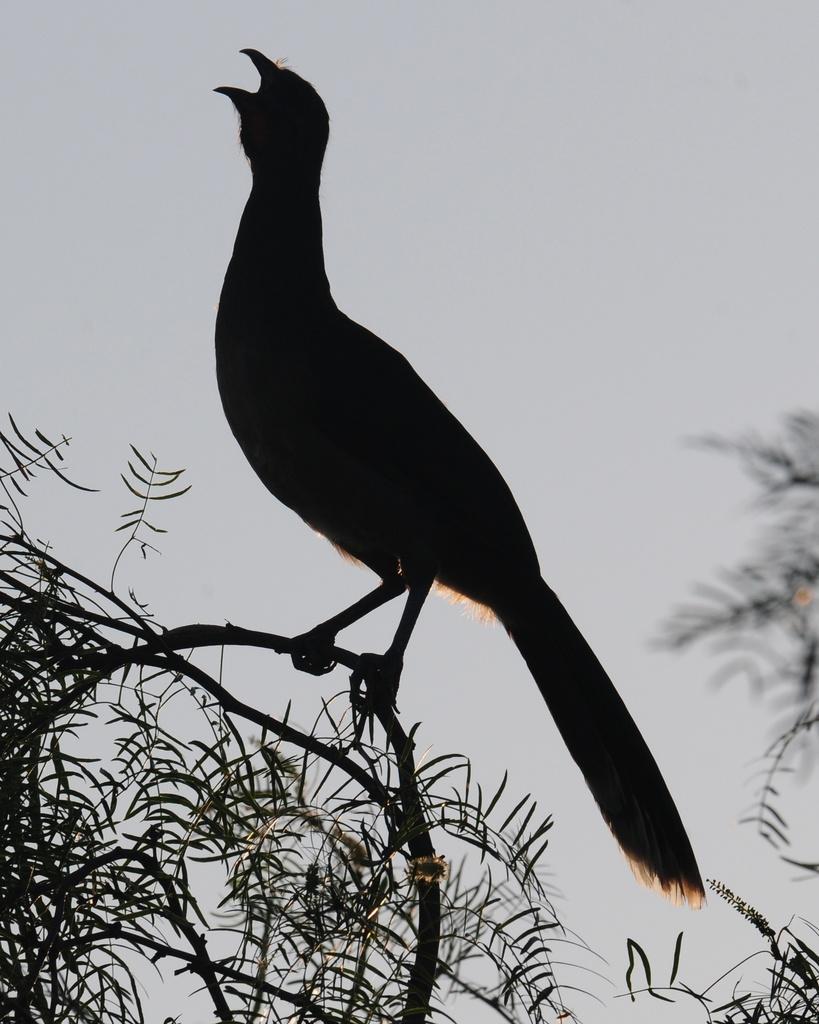Please provide a concise description of this image. In this picture we can see a bird on the branch. On the left and right side of the image there are trees. Behind the bird there is the sky. 